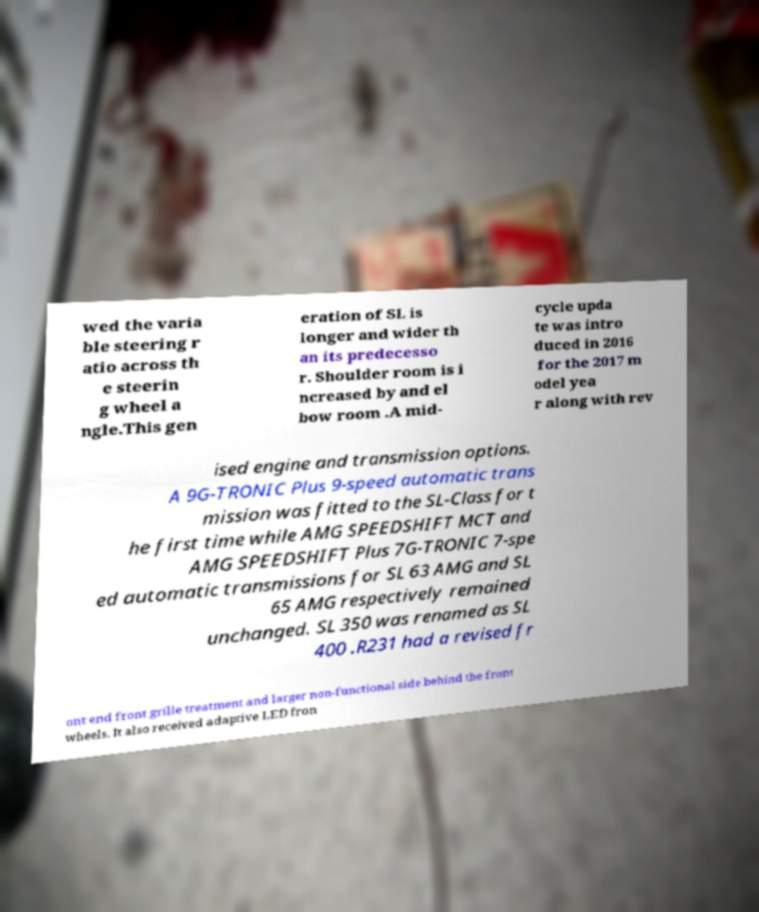What messages or text are displayed in this image? I need them in a readable, typed format. wed the varia ble steering r atio across th e steerin g wheel a ngle.This gen eration of SL is longer and wider th an its predecesso r. Shoulder room is i ncreased by and el bow room .A mid- cycle upda te was intro duced in 2016 for the 2017 m odel yea r along with rev ised engine and transmission options. A 9G-TRONIC Plus 9-speed automatic trans mission was fitted to the SL-Class for t he first time while AMG SPEEDSHIFT MCT and AMG SPEEDSHIFT Plus 7G-TRONIC 7-spe ed automatic transmissions for SL 63 AMG and SL 65 AMG respectively remained unchanged. SL 350 was renamed as SL 400 .R231 had a revised fr ont end front grille treatment and larger non-functional side behind the front wheels. It also received adaptive LED fron 